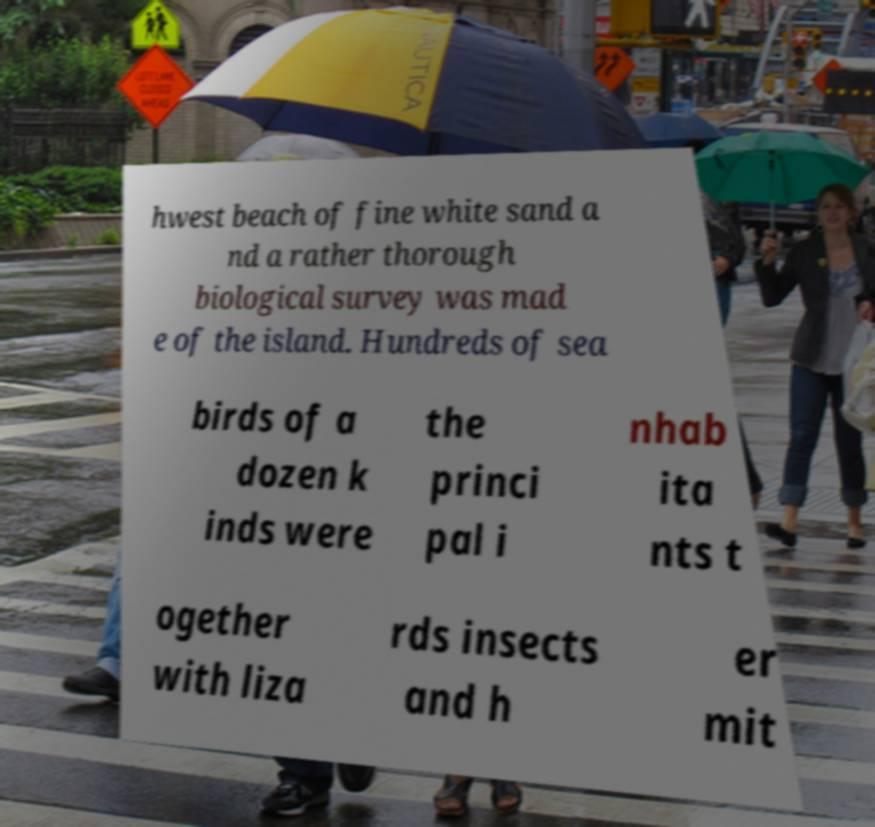Can you accurately transcribe the text from the provided image for me? hwest beach of fine white sand a nd a rather thorough biological survey was mad e of the island. Hundreds of sea birds of a dozen k inds were the princi pal i nhab ita nts t ogether with liza rds insects and h er mit 